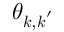Convert formula to latex. <formula><loc_0><loc_0><loc_500><loc_500>\theta _ { k , k ^ { \prime } }</formula> 